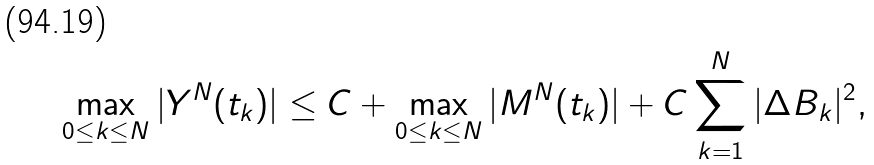Convert formula to latex. <formula><loc_0><loc_0><loc_500><loc_500>\max _ { 0 \leq k \leq N } | Y ^ { N } ( t _ { k } ) | & \leq C + \max _ { 0 \leq k \leq N } | M ^ { N } ( t _ { k } ) | + C \sum _ { k = 1 } ^ { N } | \Delta B _ { k } | ^ { 2 } ,</formula> 